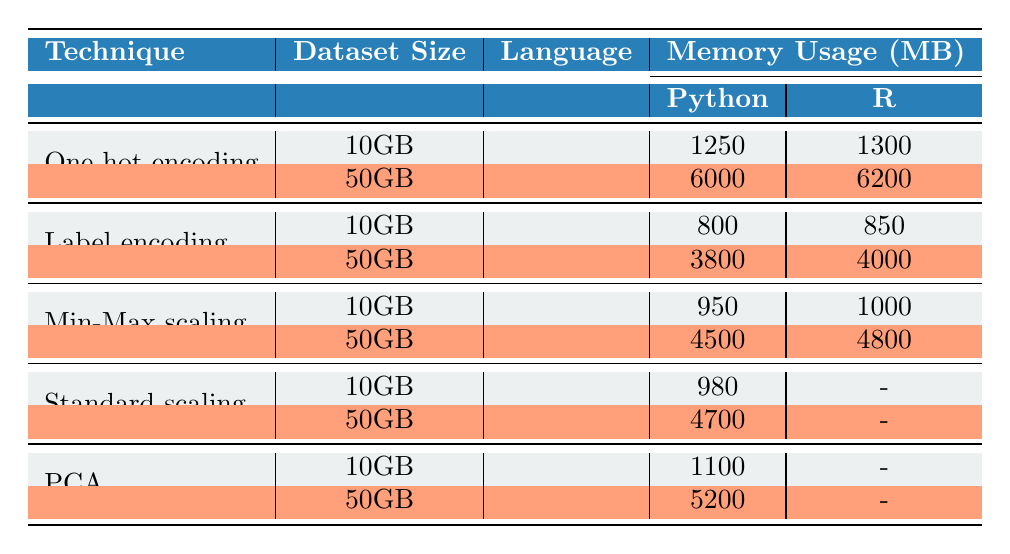What is the memory usage for One-hot encoding on a 50GB dataset in Python? The table shows the memory usage for One-hot encoding on a 50GB dataset in Python as 6000 MB.
Answer: 6000 MB What is the processing time for Label encoding on a 10GB dataset in R? According to the table, the processing time for Label encoding on a 10GB dataset in R is 130 seconds.
Answer: 130 seconds What is the difference in memory usage for Min-Max scaling between 10GB and 50GB datasets in Python? The memory usage for Min-Max scaling on a 10GB dataset is 950 MB, while it is 4500 MB for the 50GB dataset. The difference is 4500 - 950 = 3550 MB.
Answer: 3550 MB Does Standard scaling have recorded memory usage values for both dataset sizes in R? The table shows that Standard scaling does not have any recorded memory usage values for the datasets in R, as indicated by the '-' symbol. Therefore, the statement is true.
Answer: No What is the average memory usage for PCA across both dataset sizes in Python? The memory usage for PCA on a 10GB dataset is 1100 MB and on a 50GB dataset is 5200 MB. To find the average, add them together: 1100 + 5200 = 6300 MB, then divide by 2, resulting in 3150 MB.
Answer: 3150 MB Which encoding technique uses less memory on a 10GB dataset, One-hot encoding or Label encoding in R? The table specifies that the memory usage for One-hot encoding on a 10GB dataset in R is 1300 MB and for Label encoding is 850 MB. Since 850 MB is less than 1300 MB, Label encoding uses less memory.
Answer: Label encoding What is the total memory usage for both Min-Max scaling datasets in Python? The memory usage for Min-Max scaling on the 10GB dataset is 950 MB and on the 50GB dataset is 4500 MB. By summing these values, we calculate: 950 + 4500 = 5450 MB.
Answer: 5450 MB Is there a significant difference in processing time between One-hot encoding and Label encoding for a 50GB dataset in R? For a 50GB dataset, One-hot encoding takes 6200 MB and Label encoding takes 4000 MB. Since 6200 - 4000 = 2200 seconds, there is a significant difference.
Answer: Yes 